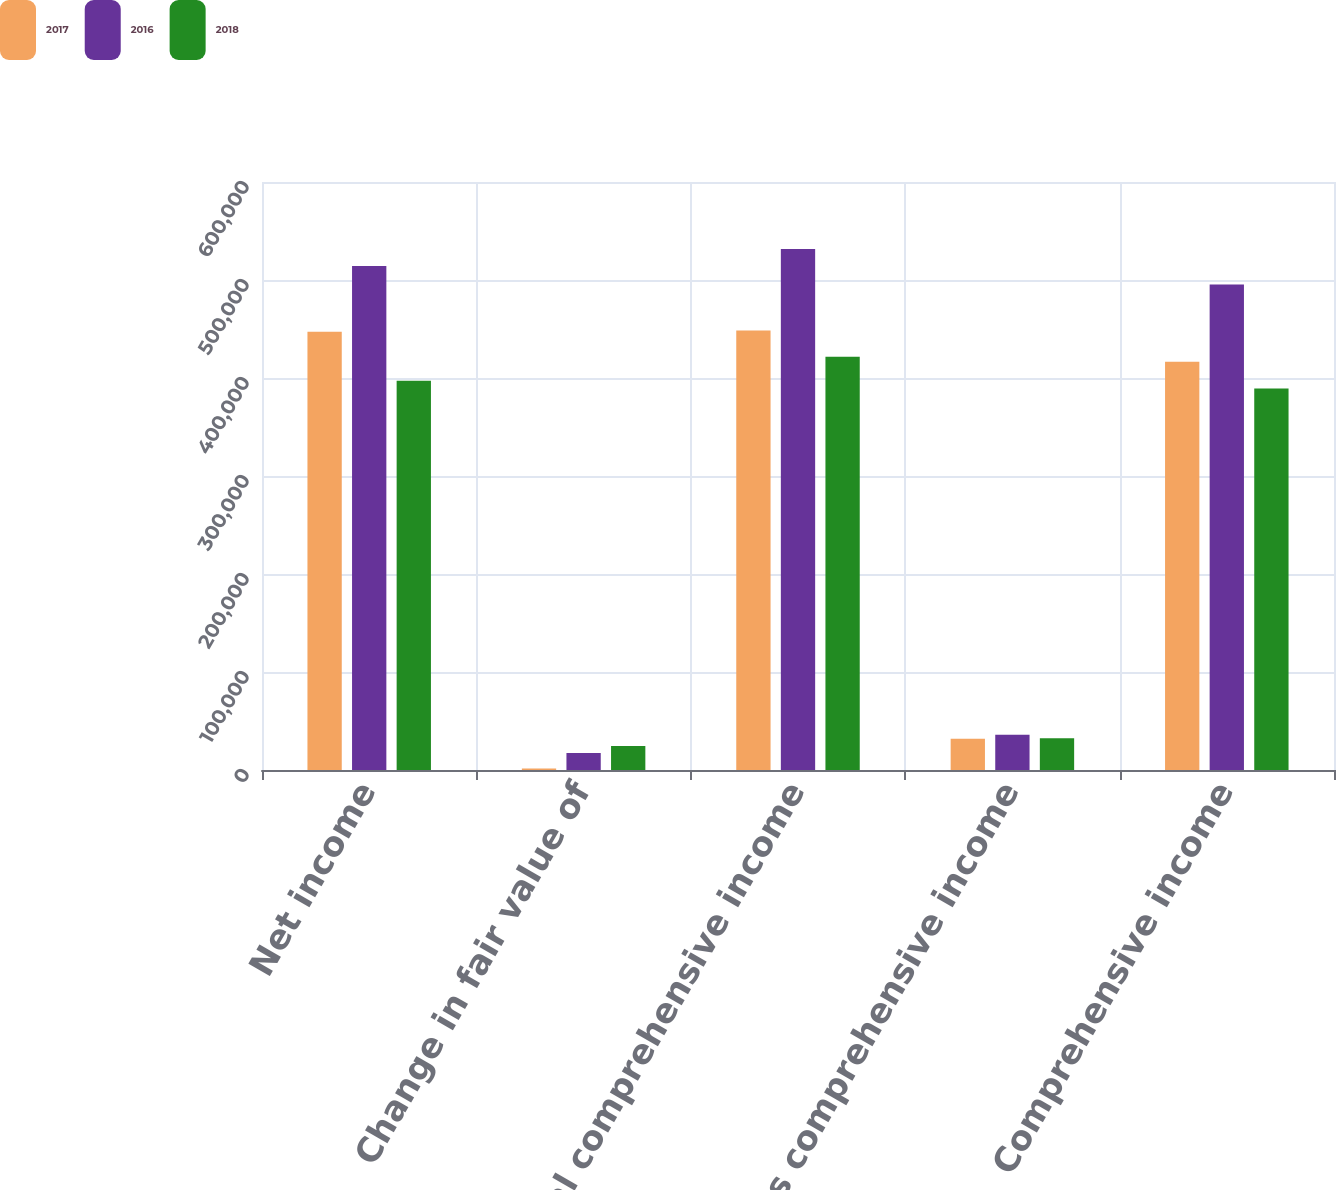Convert chart. <chart><loc_0><loc_0><loc_500><loc_500><stacked_bar_chart><ecel><fcel>Net income<fcel>Change in fair value of<fcel>Total comprehensive income<fcel>Less comprehensive income<fcel>Comprehensive income<nl><fcel>2017<fcel>447080<fcel>1430<fcel>448510<fcel>31861<fcel>416649<nl><fcel>2016<fcel>514222<fcel>17308<fcel>531530<fcel>35997<fcel>495533<nl><fcel>2018<fcel>397089<fcel>24598<fcel>421687<fcel>32438<fcel>389249<nl></chart> 